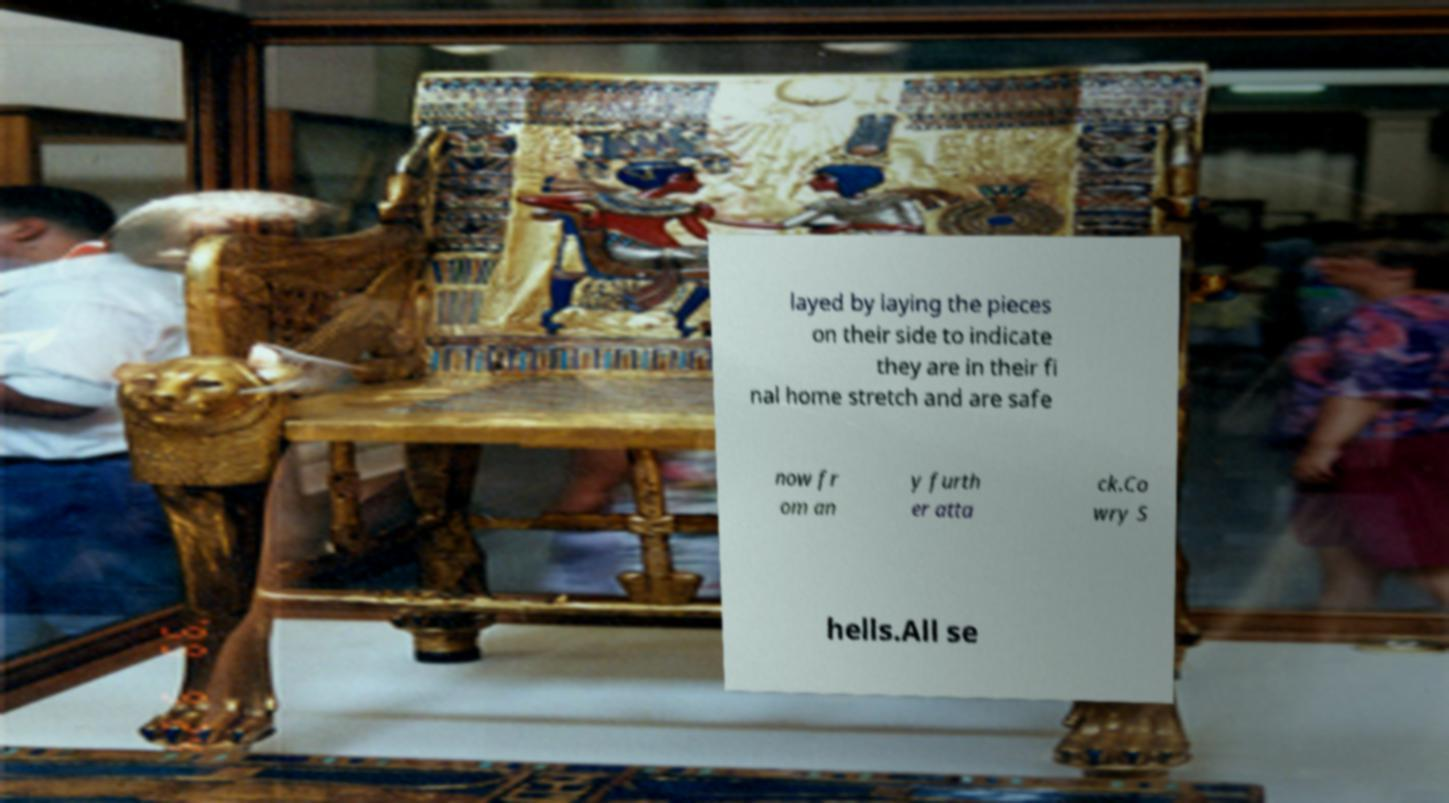For documentation purposes, I need the text within this image transcribed. Could you provide that? layed by laying the pieces on their side to indicate they are in their fi nal home stretch and are safe now fr om an y furth er atta ck.Co wry S hells.All se 